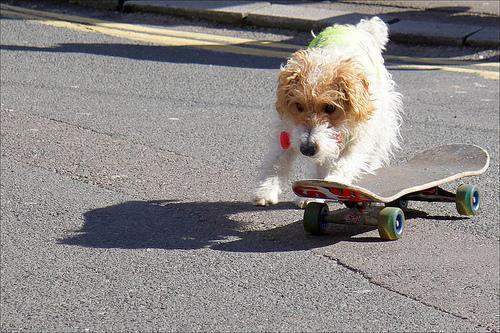How many legs does the dog have?
Give a very brief answer. 4. How many wheels does the skateboard have?
Give a very brief answer. 4. 